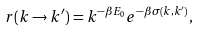Convert formula to latex. <formula><loc_0><loc_0><loc_500><loc_500>r ( k \rightarrow k ^ { \prime } ) = k ^ { - \beta E _ { 0 } } e ^ { - \beta \sigma ( k , k ^ { \prime } ) } ,</formula> 